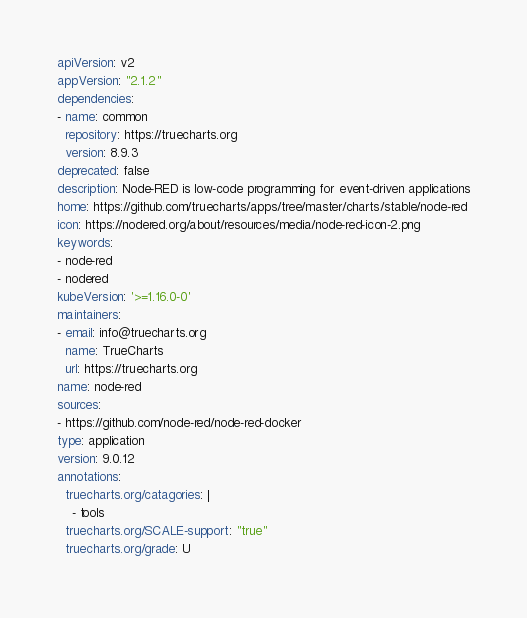Convert code to text. <code><loc_0><loc_0><loc_500><loc_500><_YAML_>apiVersion: v2
appVersion: "2.1.2"
dependencies:
- name: common
  repository: https://truecharts.org
  version: 8.9.3
deprecated: false
description: Node-RED is low-code programming for event-driven applications
home: https://github.com/truecharts/apps/tree/master/charts/stable/node-red
icon: https://nodered.org/about/resources/media/node-red-icon-2.png
keywords:
- node-red
- nodered
kubeVersion: '>=1.16.0-0'
maintainers:
- email: info@truecharts.org
  name: TrueCharts
  url: https://truecharts.org
name: node-red
sources:
- https://github.com/node-red/node-red-docker
type: application
version: 9.0.12
annotations:
  truecharts.org/catagories: |
    - tools
  truecharts.org/SCALE-support: "true"
  truecharts.org/grade: U
</code> 